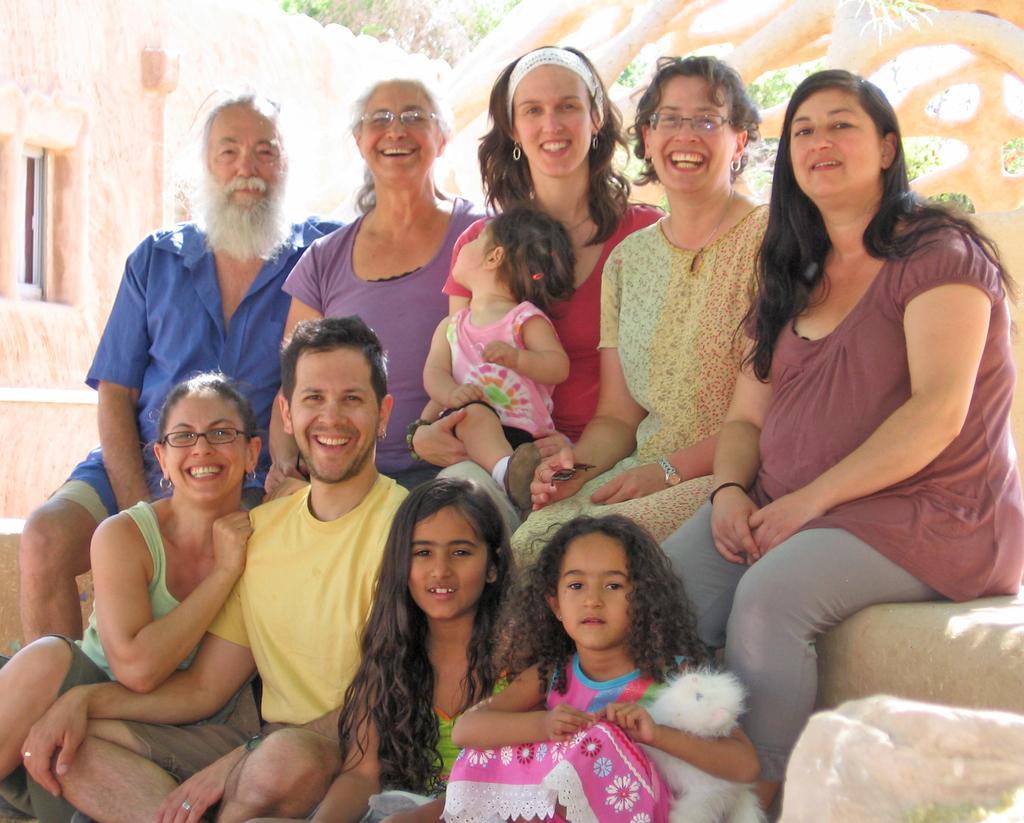Can you describe this image briefly? In this picture I can see number of people in front and I see that all of them are sitting. I can also see that most of them are smiling. I see that the girl on the right is holding a thing. In the background I can see a building and the trees. 